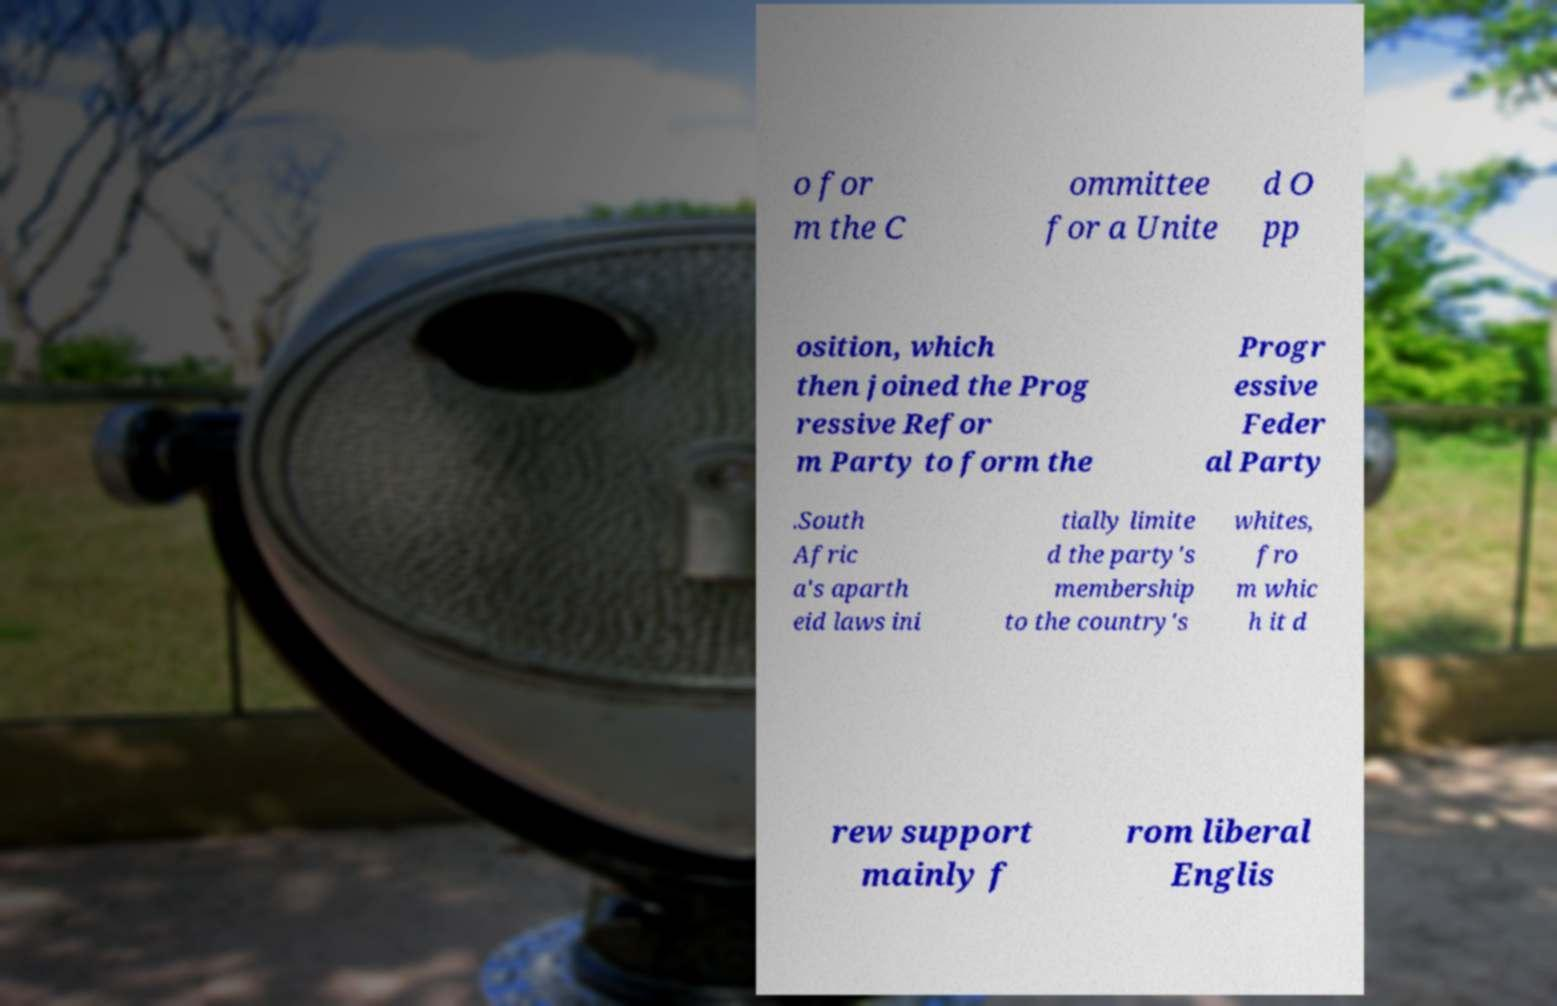What messages or text are displayed in this image? I need them in a readable, typed format. o for m the C ommittee for a Unite d O pp osition, which then joined the Prog ressive Refor m Party to form the Progr essive Feder al Party .South Afric a's aparth eid laws ini tially limite d the party's membership to the country's whites, fro m whic h it d rew support mainly f rom liberal Englis 